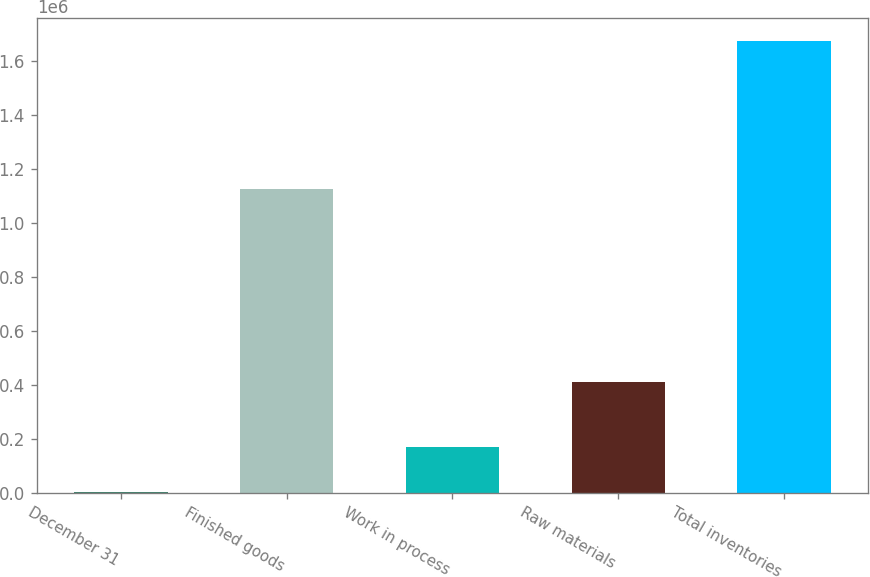Convert chart. <chart><loc_0><loc_0><loc_500><loc_500><bar_chart><fcel>December 31<fcel>Finished goods<fcel>Work in process<fcel>Raw materials<fcel>Total inventories<nl><fcel>2016<fcel>1.12757e+06<fcel>169390<fcel>410868<fcel>1.67575e+06<nl></chart> 